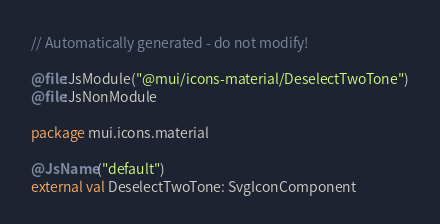Convert code to text. <code><loc_0><loc_0><loc_500><loc_500><_Kotlin_>// Automatically generated - do not modify!

@file:JsModule("@mui/icons-material/DeselectTwoTone")
@file:JsNonModule

package mui.icons.material

@JsName("default")
external val DeselectTwoTone: SvgIconComponent
</code> 